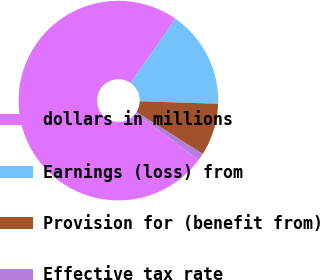Convert chart. <chart><loc_0><loc_0><loc_500><loc_500><pie_chart><fcel>dollars in millions<fcel>Earnings (loss) from<fcel>Provision for (benefit from)<fcel>Effective tax rate<nl><fcel>74.56%<fcel>15.82%<fcel>8.48%<fcel>1.14%<nl></chart> 